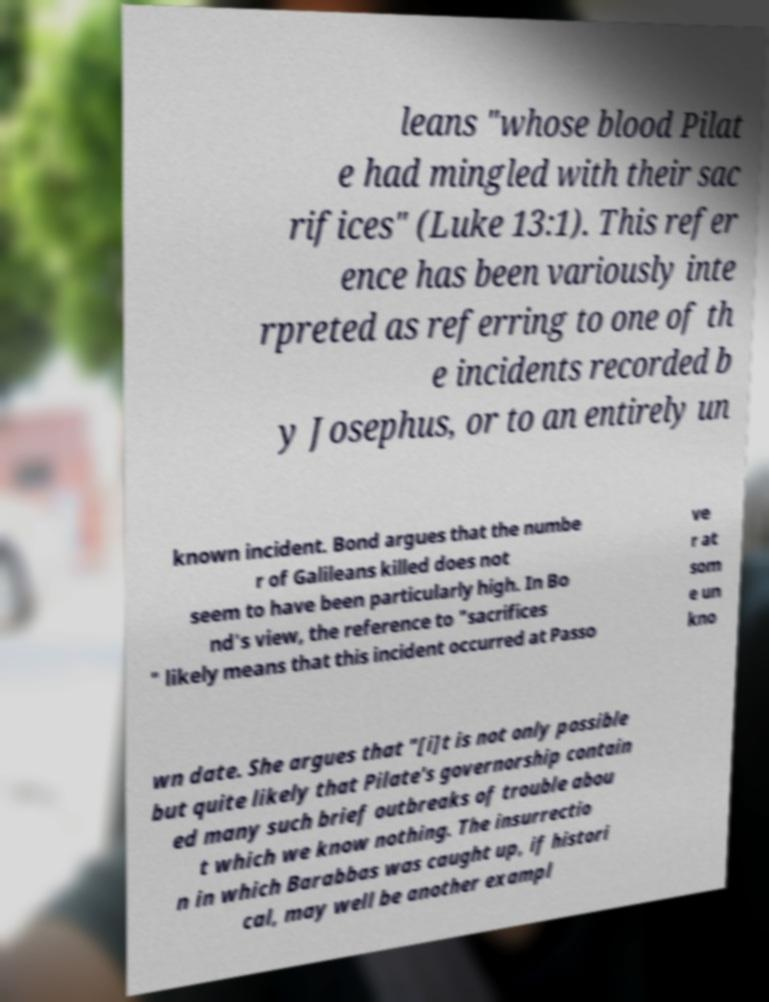Could you assist in decoding the text presented in this image and type it out clearly? leans "whose blood Pilat e had mingled with their sac rifices" (Luke 13:1). This refer ence has been variously inte rpreted as referring to one of th e incidents recorded b y Josephus, or to an entirely un known incident. Bond argues that the numbe r of Galileans killed does not seem to have been particularly high. In Bo nd's view, the reference to "sacrifices " likely means that this incident occurred at Passo ve r at som e un kno wn date. She argues that "[i]t is not only possible but quite likely that Pilate's governorship contain ed many such brief outbreaks of trouble abou t which we know nothing. The insurrectio n in which Barabbas was caught up, if histori cal, may well be another exampl 